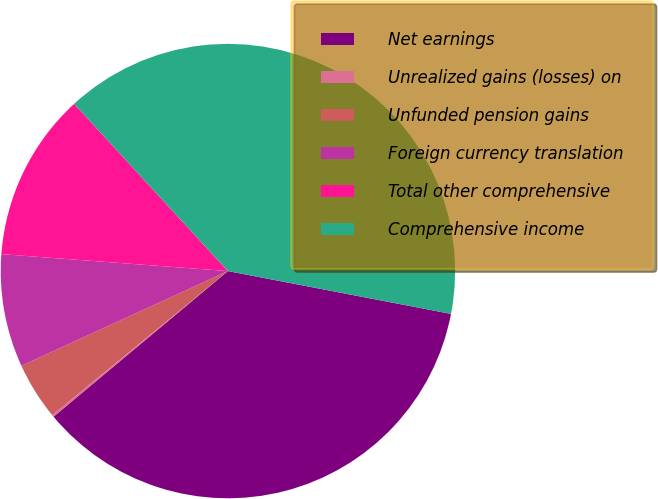<chart> <loc_0><loc_0><loc_500><loc_500><pie_chart><fcel>Net earnings<fcel>Unrealized gains (losses) on<fcel>Unfunded pension gains<fcel>Foreign currency translation<fcel>Total other comprehensive<fcel>Comprehensive income<nl><fcel>35.91%<fcel>0.14%<fcel>4.09%<fcel>8.03%<fcel>11.98%<fcel>39.85%<nl></chart> 